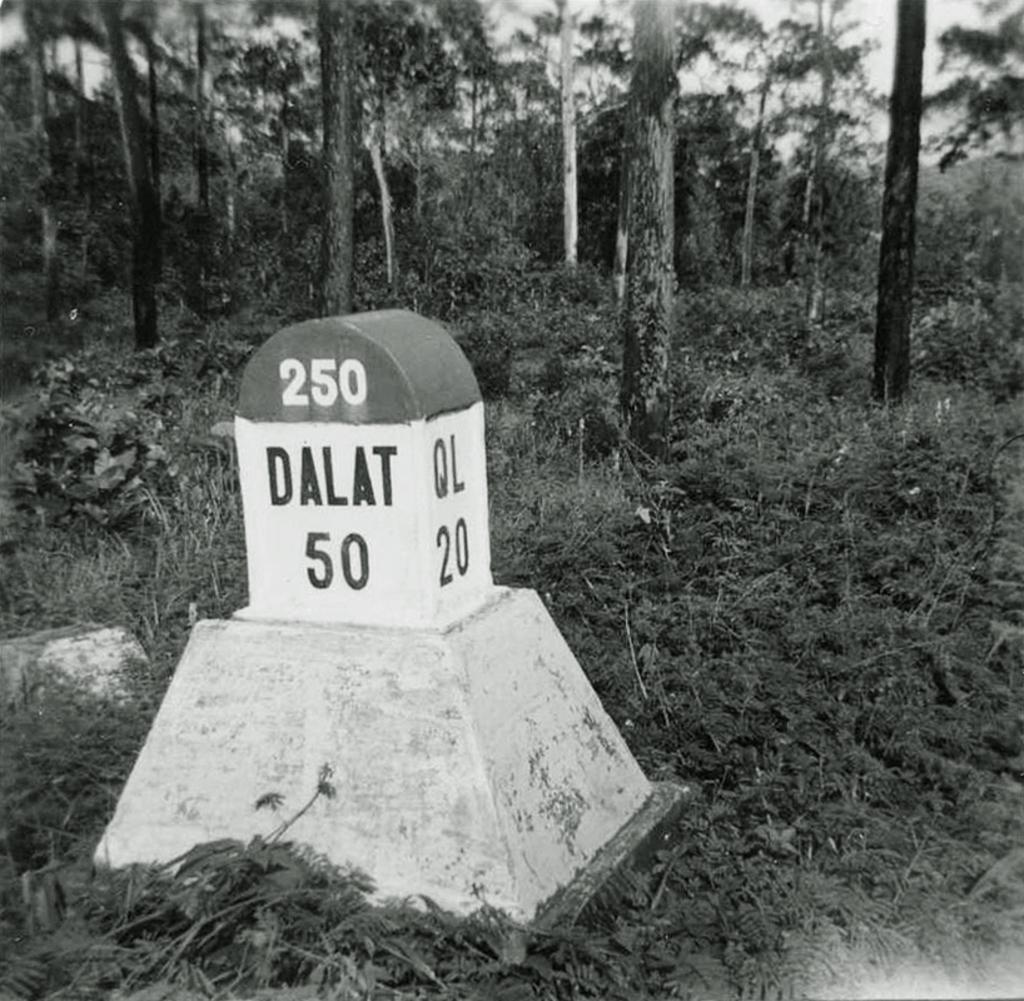What is the color scheme of the image? The image is black and white. What is the main object in the image? There is a milestone in the image. What information is displayed on the milestone? The milestone has readings on it. What type of natural environment is visible in the background of the image? There is grass, plants, and trees visible in the background of the image. Can you see any chickens near the milestone in the image? There are no chickens present in the image. Is the milestone a print or a physical object in the image? The milestone is a physical object in the image, not a print. 